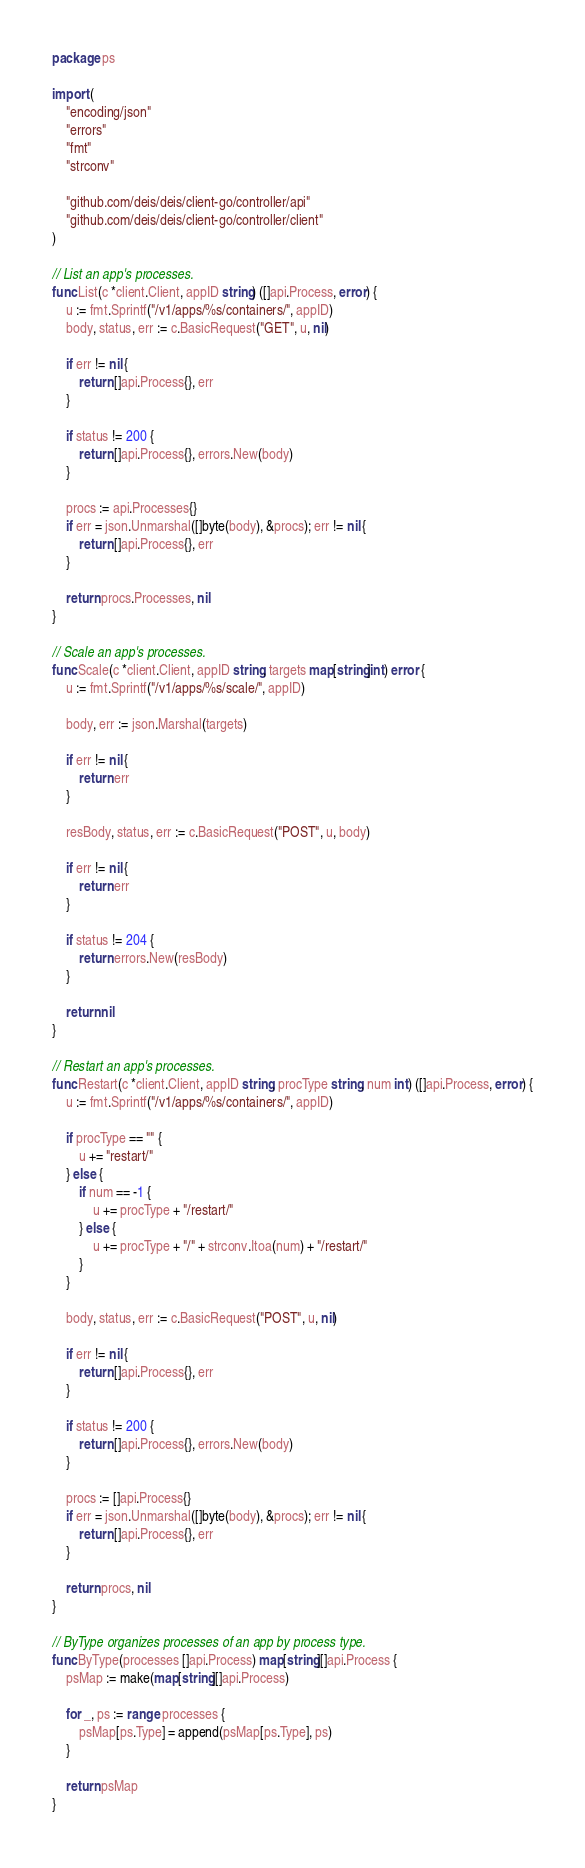Convert code to text. <code><loc_0><loc_0><loc_500><loc_500><_Go_>package ps

import (
	"encoding/json"
	"errors"
	"fmt"
	"strconv"

	"github.com/deis/deis/client-go/controller/api"
	"github.com/deis/deis/client-go/controller/client"
)

// List an app's processes.
func List(c *client.Client, appID string) ([]api.Process, error) {
	u := fmt.Sprintf("/v1/apps/%s/containers/", appID)
	body, status, err := c.BasicRequest("GET", u, nil)

	if err != nil {
		return []api.Process{}, err
	}

	if status != 200 {
		return []api.Process{}, errors.New(body)
	}

	procs := api.Processes{}
	if err = json.Unmarshal([]byte(body), &procs); err != nil {
		return []api.Process{}, err
	}

	return procs.Processes, nil
}

// Scale an app's processes.
func Scale(c *client.Client, appID string, targets map[string]int) error {
	u := fmt.Sprintf("/v1/apps/%s/scale/", appID)

	body, err := json.Marshal(targets)

	if err != nil {
		return err
	}

	resBody, status, err := c.BasicRequest("POST", u, body)

	if err != nil {
		return err
	}

	if status != 204 {
		return errors.New(resBody)
	}

	return nil
}

// Restart an app's processes.
func Restart(c *client.Client, appID string, procType string, num int) ([]api.Process, error) {
	u := fmt.Sprintf("/v1/apps/%s/containers/", appID)

	if procType == "" {
		u += "restart/"
	} else {
		if num == -1 {
			u += procType + "/restart/"
		} else {
			u += procType + "/" + strconv.Itoa(num) + "/restart/"
		}
	}

	body, status, err := c.BasicRequest("POST", u, nil)

	if err != nil {
		return []api.Process{}, err
	}

	if status != 200 {
		return []api.Process{}, errors.New(body)
	}

	procs := []api.Process{}
	if err = json.Unmarshal([]byte(body), &procs); err != nil {
		return []api.Process{}, err
	}

	return procs, nil
}

// ByType organizes processes of an app by process type.
func ByType(processes []api.Process) map[string][]api.Process {
	psMap := make(map[string][]api.Process)

	for _, ps := range processes {
		psMap[ps.Type] = append(psMap[ps.Type], ps)
	}

	return psMap
}
</code> 